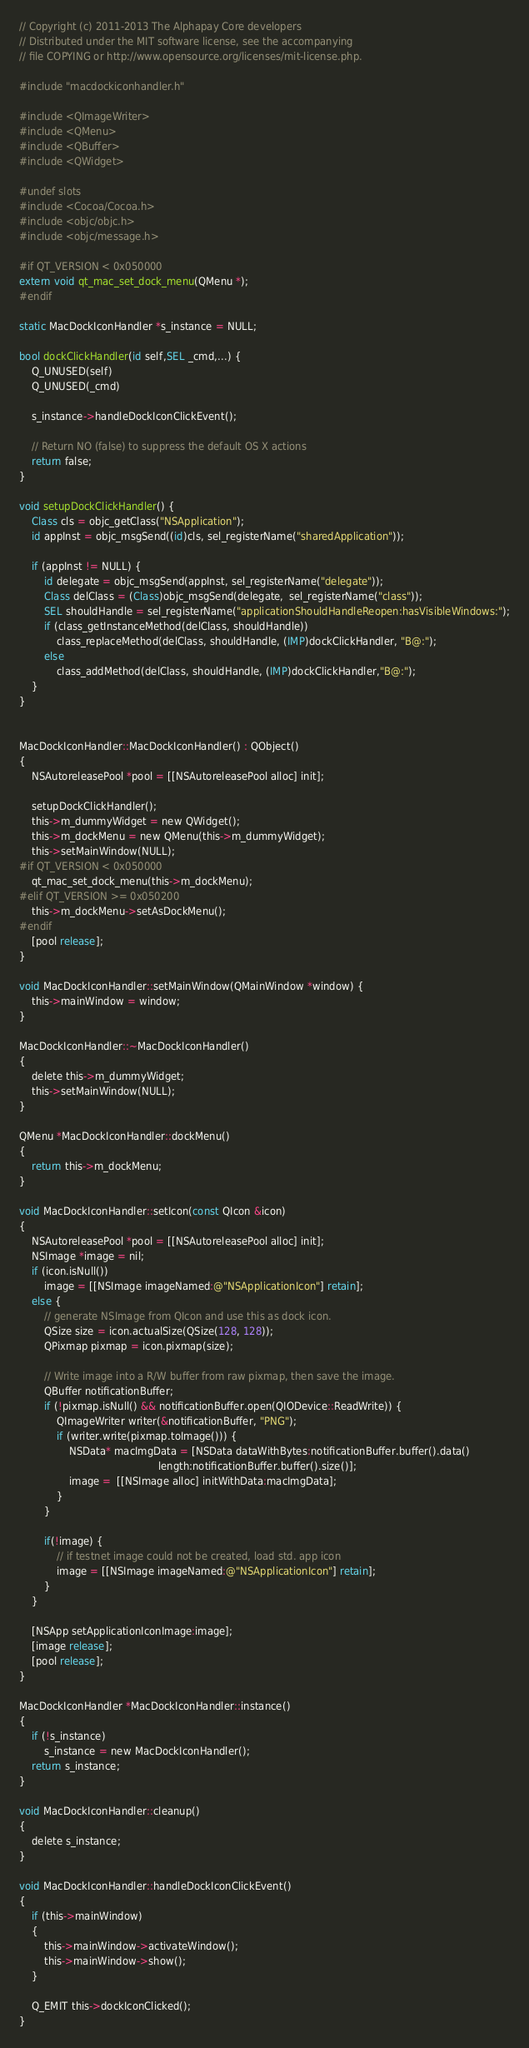Convert code to text. <code><loc_0><loc_0><loc_500><loc_500><_ObjectiveC_>// Copyright (c) 2011-2013 The Alphapay Core developers
// Distributed under the MIT software license, see the accompanying
// file COPYING or http://www.opensource.org/licenses/mit-license.php.

#include "macdockiconhandler.h"

#include <QImageWriter>
#include <QMenu>
#include <QBuffer>
#include <QWidget>

#undef slots
#include <Cocoa/Cocoa.h>
#include <objc/objc.h>
#include <objc/message.h>

#if QT_VERSION < 0x050000
extern void qt_mac_set_dock_menu(QMenu *);
#endif

static MacDockIconHandler *s_instance = NULL;

bool dockClickHandler(id self,SEL _cmd,...) {
    Q_UNUSED(self)
    Q_UNUSED(_cmd)
    
    s_instance->handleDockIconClickEvent();
    
    // Return NO (false) to suppress the default OS X actions
    return false;
}

void setupDockClickHandler() {
    Class cls = objc_getClass("NSApplication");
    id appInst = objc_msgSend((id)cls, sel_registerName("sharedApplication"));
    
    if (appInst != NULL) {
        id delegate = objc_msgSend(appInst, sel_registerName("delegate"));
        Class delClass = (Class)objc_msgSend(delegate,  sel_registerName("class"));
        SEL shouldHandle = sel_registerName("applicationShouldHandleReopen:hasVisibleWindows:");
        if (class_getInstanceMethod(delClass, shouldHandle))
            class_replaceMethod(delClass, shouldHandle, (IMP)dockClickHandler, "B@:");
        else
            class_addMethod(delClass, shouldHandle, (IMP)dockClickHandler,"B@:");
    }
}


MacDockIconHandler::MacDockIconHandler() : QObject()
{
    NSAutoreleasePool *pool = [[NSAutoreleasePool alloc] init];

    setupDockClickHandler();
    this->m_dummyWidget = new QWidget();
    this->m_dockMenu = new QMenu(this->m_dummyWidget);
    this->setMainWindow(NULL);
#if QT_VERSION < 0x050000
    qt_mac_set_dock_menu(this->m_dockMenu);
#elif QT_VERSION >= 0x050200
    this->m_dockMenu->setAsDockMenu();
#endif
    [pool release];
}

void MacDockIconHandler::setMainWindow(QMainWindow *window) {
    this->mainWindow = window;
}

MacDockIconHandler::~MacDockIconHandler()
{
    delete this->m_dummyWidget;
    this->setMainWindow(NULL);
}

QMenu *MacDockIconHandler::dockMenu()
{
    return this->m_dockMenu;
}

void MacDockIconHandler::setIcon(const QIcon &icon)
{
    NSAutoreleasePool *pool = [[NSAutoreleasePool alloc] init];
    NSImage *image = nil;
    if (icon.isNull())
        image = [[NSImage imageNamed:@"NSApplicationIcon"] retain];
    else {
        // generate NSImage from QIcon and use this as dock icon.
        QSize size = icon.actualSize(QSize(128, 128));
        QPixmap pixmap = icon.pixmap(size);

        // Write image into a R/W buffer from raw pixmap, then save the image.
        QBuffer notificationBuffer;
        if (!pixmap.isNull() && notificationBuffer.open(QIODevice::ReadWrite)) {
            QImageWriter writer(&notificationBuffer, "PNG");
            if (writer.write(pixmap.toImage())) {
                NSData* macImgData = [NSData dataWithBytes:notificationBuffer.buffer().data()
                                             length:notificationBuffer.buffer().size()];
                image =  [[NSImage alloc] initWithData:macImgData];
            }
        }

        if(!image) {
            // if testnet image could not be created, load std. app icon
            image = [[NSImage imageNamed:@"NSApplicationIcon"] retain];
        }
    }

    [NSApp setApplicationIconImage:image];
    [image release];
    [pool release];
}

MacDockIconHandler *MacDockIconHandler::instance()
{
    if (!s_instance)
        s_instance = new MacDockIconHandler();
    return s_instance;
}

void MacDockIconHandler::cleanup()
{
    delete s_instance;
}

void MacDockIconHandler::handleDockIconClickEvent()
{
    if (this->mainWindow)
    {
        this->mainWindow->activateWindow();
        this->mainWindow->show();
    }

    Q_EMIT this->dockIconClicked();
}
</code> 